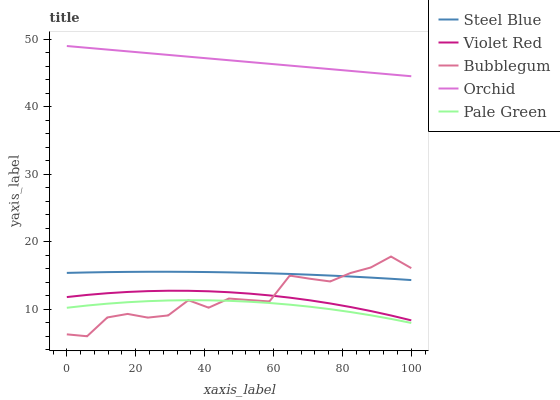Does Steel Blue have the minimum area under the curve?
Answer yes or no. No. Does Steel Blue have the maximum area under the curve?
Answer yes or no. No. Is Pale Green the smoothest?
Answer yes or no. No. Is Pale Green the roughest?
Answer yes or no. No. Does Pale Green have the lowest value?
Answer yes or no. No. Does Steel Blue have the highest value?
Answer yes or no. No. Is Pale Green less than Orchid?
Answer yes or no. Yes. Is Orchid greater than Bubblegum?
Answer yes or no. Yes. Does Pale Green intersect Orchid?
Answer yes or no. No. 